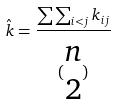<formula> <loc_0><loc_0><loc_500><loc_500>\hat { k } = \frac { \sum \sum _ { i < j } k _ { i j } } { ( \begin{matrix} n \\ 2 \end{matrix} ) }</formula> 